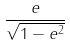<formula> <loc_0><loc_0><loc_500><loc_500>\frac { e } { \sqrt { 1 - e ^ { 2 } } }</formula> 